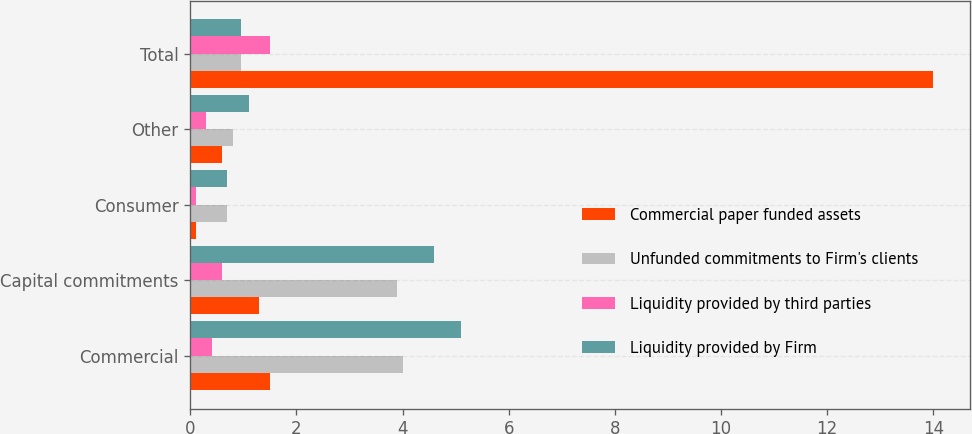Convert chart to OTSL. <chart><loc_0><loc_0><loc_500><loc_500><stacked_bar_chart><ecel><fcel>Commercial<fcel>Capital commitments<fcel>Consumer<fcel>Other<fcel>Total<nl><fcel>Commercial paper funded assets<fcel>1.5<fcel>1.3<fcel>0.1<fcel>0.6<fcel>14<nl><fcel>Unfunded commitments to Firm's clients<fcel>4<fcel>3.9<fcel>0.7<fcel>0.8<fcel>0.95<nl><fcel>Liquidity provided by third parties<fcel>0.4<fcel>0.6<fcel>0.1<fcel>0.3<fcel>1.5<nl><fcel>Liquidity provided by Firm<fcel>5.1<fcel>4.6<fcel>0.7<fcel>1.1<fcel>0.95<nl></chart> 